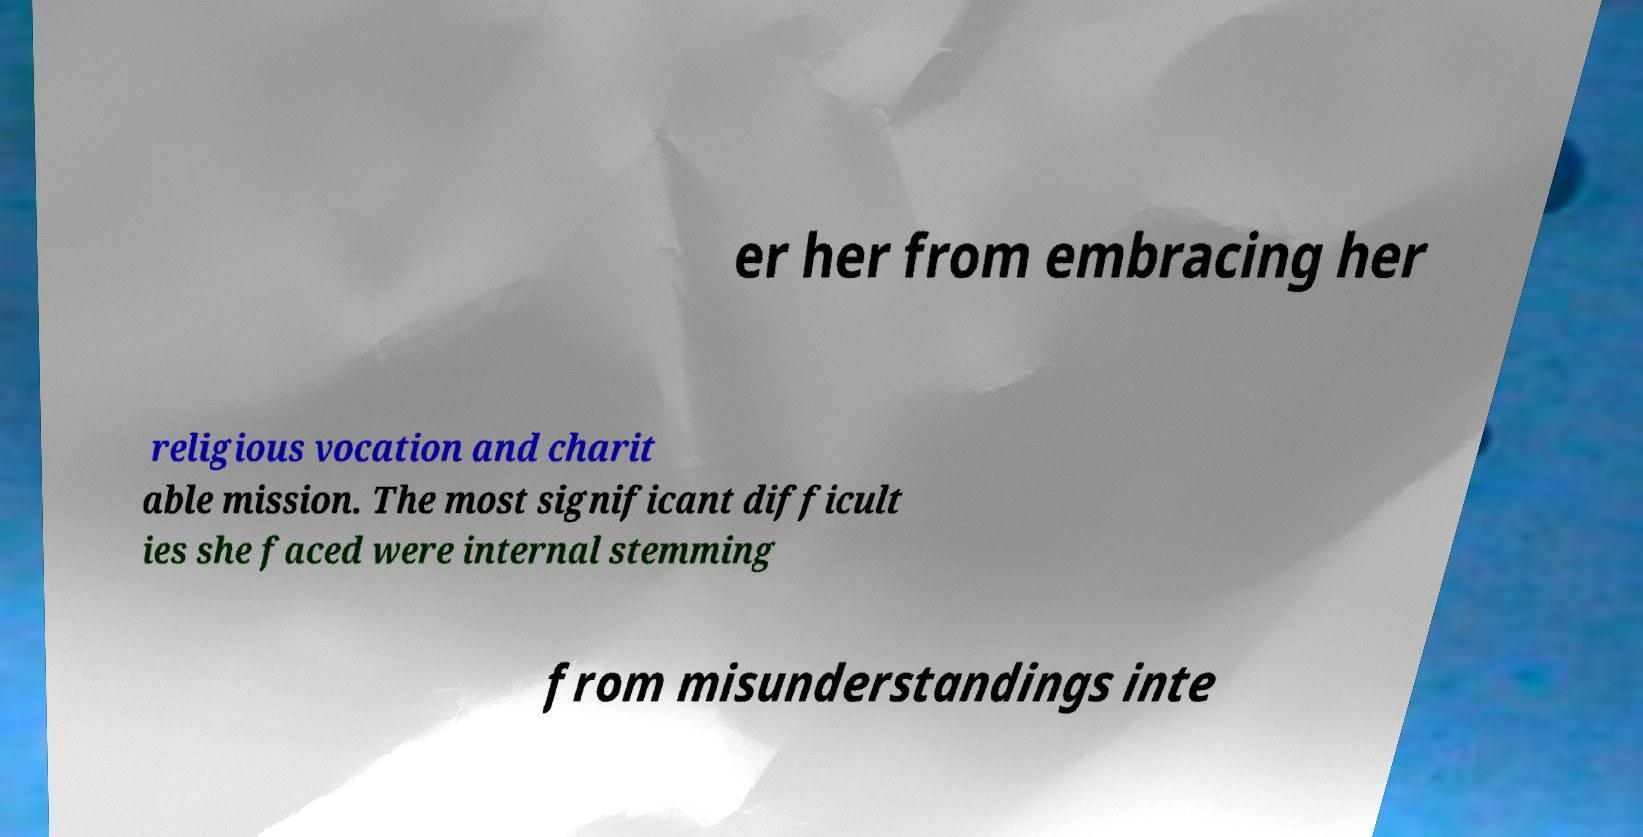Could you extract and type out the text from this image? er her from embracing her religious vocation and charit able mission. The most significant difficult ies she faced were internal stemming from misunderstandings inte 